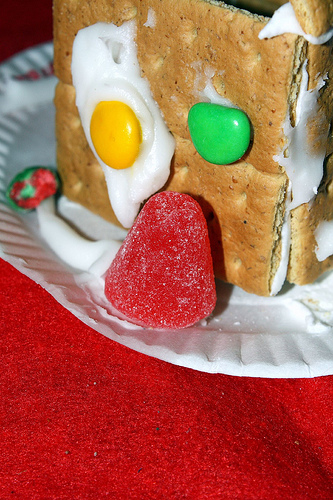<image>
Is there a candy above the plate? Yes. The candy is positioned above the plate in the vertical space, higher up in the scene. 